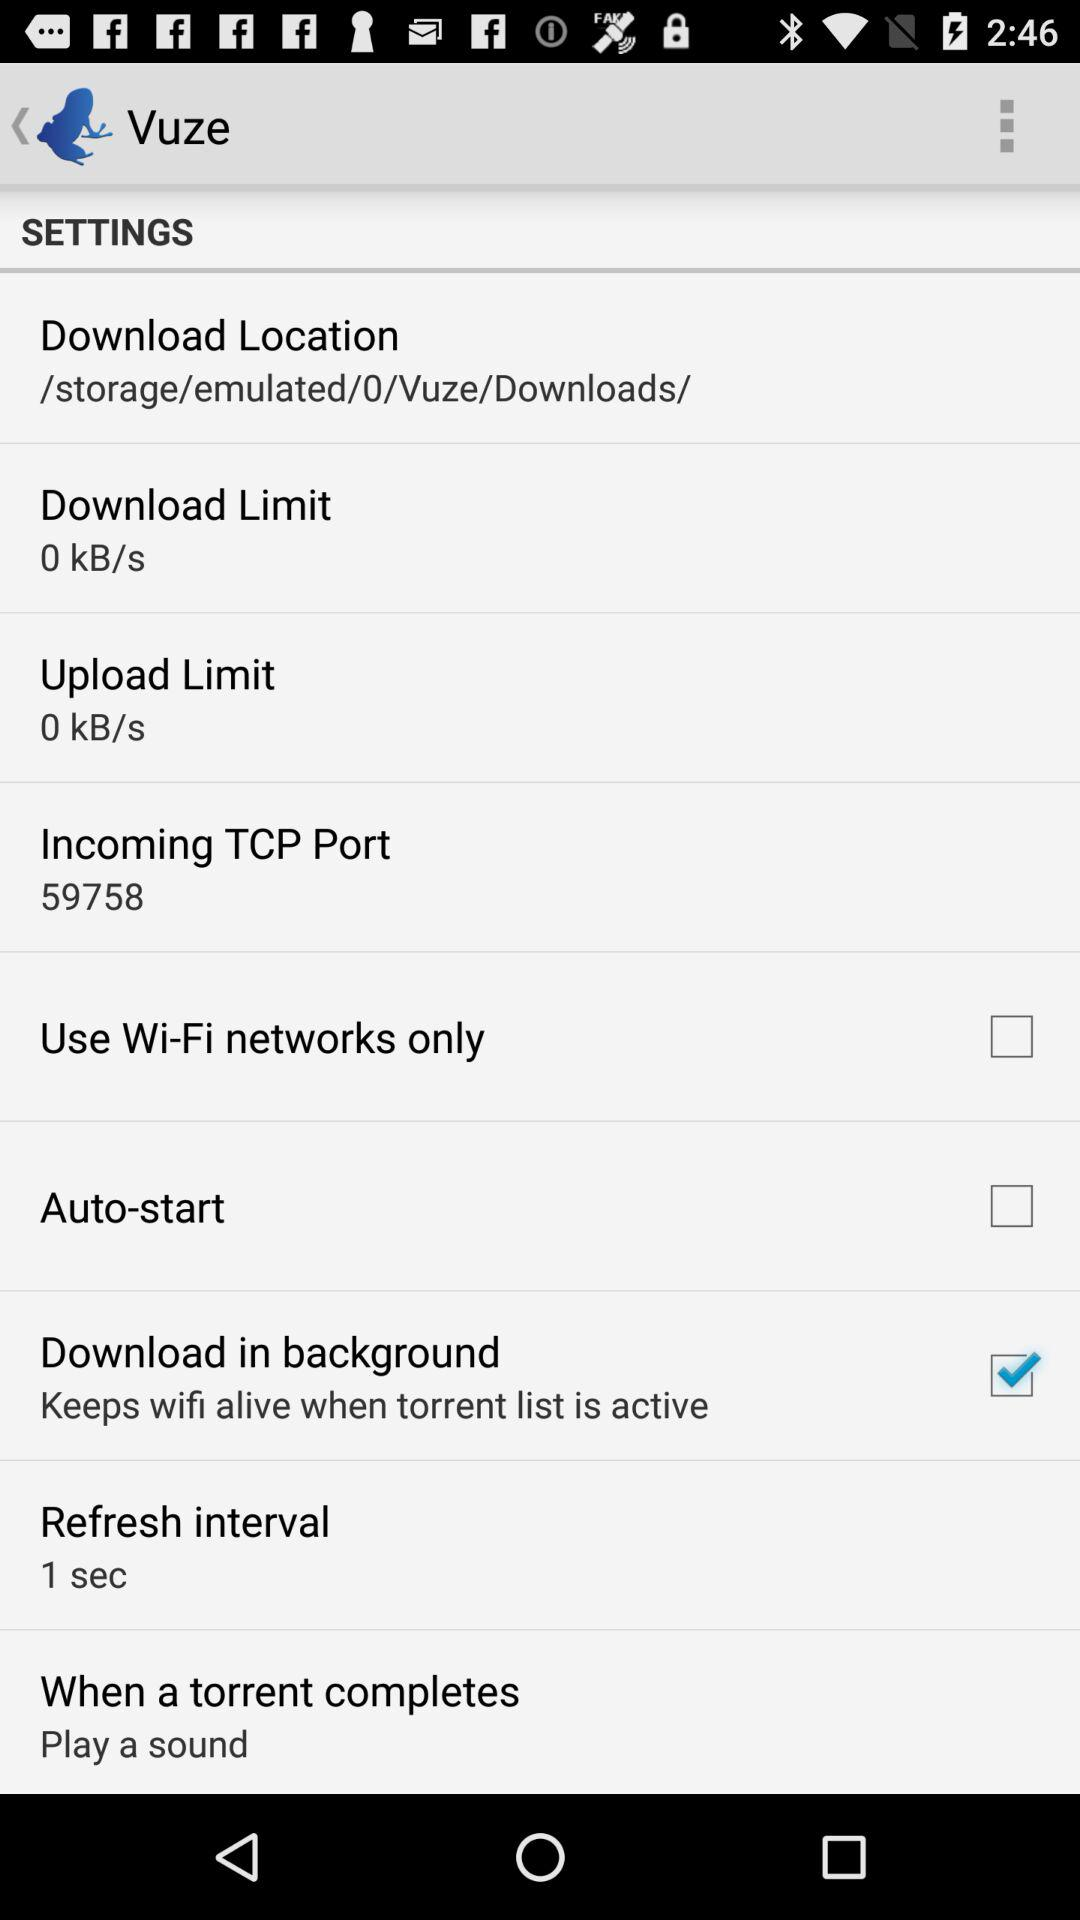What is the status of "Auto-start"? The status is "off". 